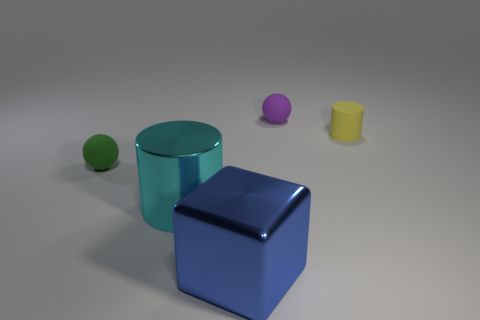Add 3 rubber spheres. How many objects exist? 8 Subtract 1 cubes. How many cubes are left? 0 Subtract all spheres. How many objects are left? 3 Subtract all cyan blocks. Subtract all blue cylinders. How many blocks are left? 1 Subtract all green rubber things. Subtract all purple rubber objects. How many objects are left? 3 Add 3 rubber cylinders. How many rubber cylinders are left? 4 Add 4 big gray objects. How many big gray objects exist? 4 Subtract 0 brown cylinders. How many objects are left? 5 